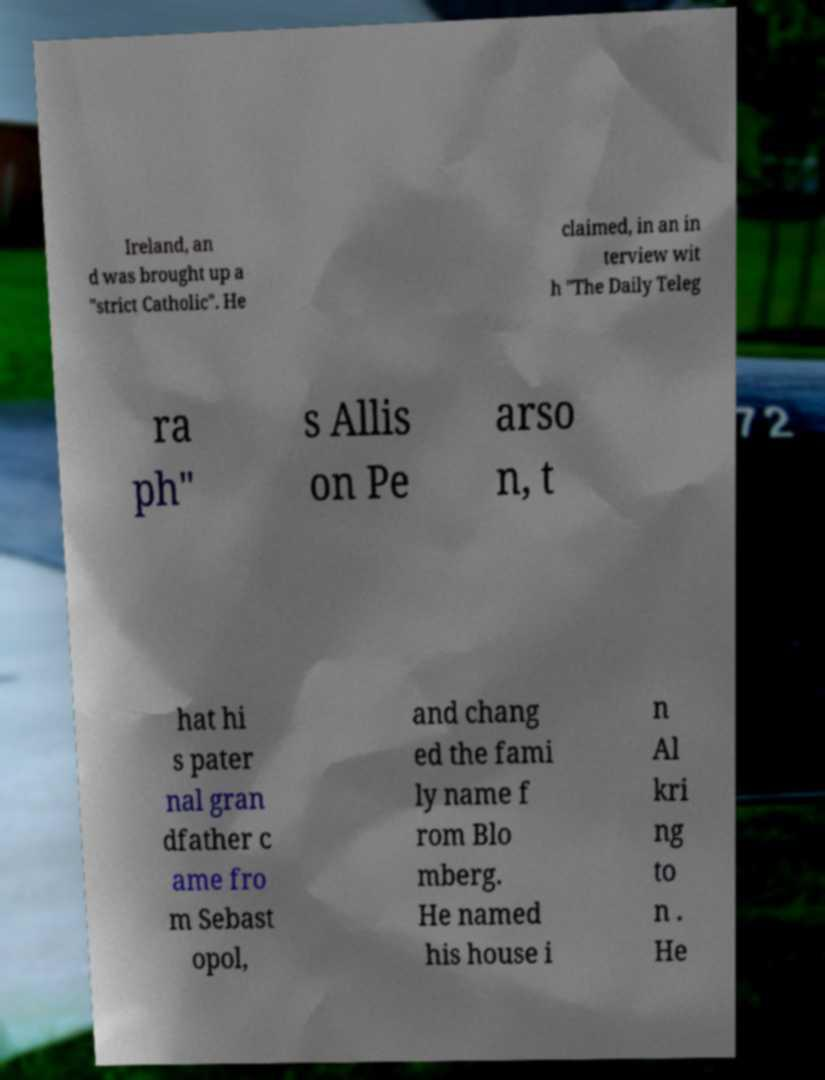There's text embedded in this image that I need extracted. Can you transcribe it verbatim? Ireland, an d was brought up a "strict Catholic". He claimed, in an in terview wit h "The Daily Teleg ra ph" s Allis on Pe arso n, t hat hi s pater nal gran dfather c ame fro m Sebast opol, and chang ed the fami ly name f rom Blo mberg. He named his house i n Al kri ng to n . He 